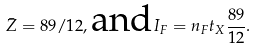Convert formula to latex. <formula><loc_0><loc_0><loc_500><loc_500>\bar { Z } = 8 9 / 1 2 , \text {and} I _ { F } = n _ { F } t _ { X } \frac { 8 9 } { 1 2 } .</formula> 